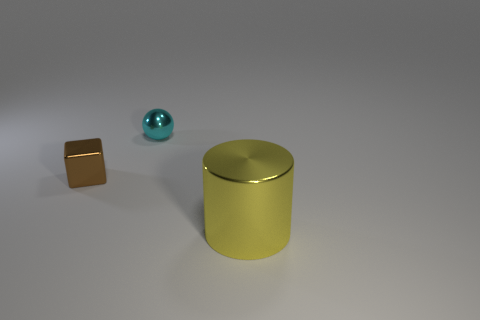Are there fewer big yellow cylinders than gray shiny things?
Give a very brief answer. No. How many small brown things have the same material as the brown cube?
Make the answer very short. 0. What color is the small block that is made of the same material as the big object?
Your response must be concise. Brown. The large yellow metallic object is what shape?
Your answer should be compact. Cylinder. How many cubes have the same color as the small sphere?
Offer a terse response. 0. What is the shape of the cyan metallic thing that is the same size as the block?
Your response must be concise. Sphere. Is there a cyan matte block of the same size as the cyan shiny thing?
Offer a very short reply. No. What is the material of the brown thing that is the same size as the cyan shiny thing?
Give a very brief answer. Metal. What size is the object on the right side of the thing that is behind the tiny brown metal object?
Your response must be concise. Large. There is a metallic thing to the right of the sphere; is it the same size as the small brown metallic block?
Your answer should be very brief. No. 